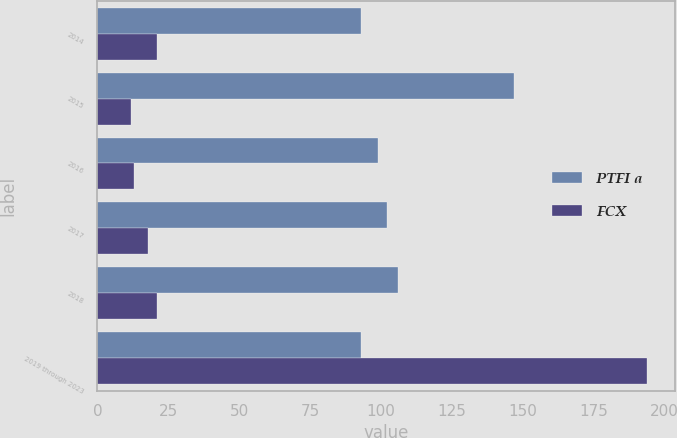Convert chart. <chart><loc_0><loc_0><loc_500><loc_500><stacked_bar_chart><ecel><fcel>2014<fcel>2015<fcel>2016<fcel>2017<fcel>2018<fcel>2019 through 2023<nl><fcel>PTFI a<fcel>93<fcel>147<fcel>99<fcel>102<fcel>106<fcel>93<nl><fcel>FCX<fcel>21<fcel>12<fcel>13<fcel>18<fcel>21<fcel>194<nl></chart> 